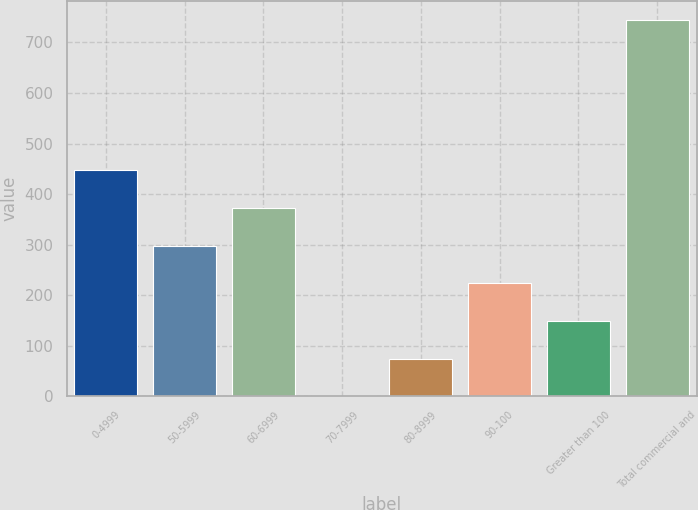<chart> <loc_0><loc_0><loc_500><loc_500><bar_chart><fcel>0-4999<fcel>50-5999<fcel>60-6999<fcel>70-7999<fcel>80-8999<fcel>90-100<fcel>Greater than 100<fcel>Total commercial and<nl><fcel>447.06<fcel>298.08<fcel>372.57<fcel>0.12<fcel>74.61<fcel>223.59<fcel>149.1<fcel>745<nl></chart> 